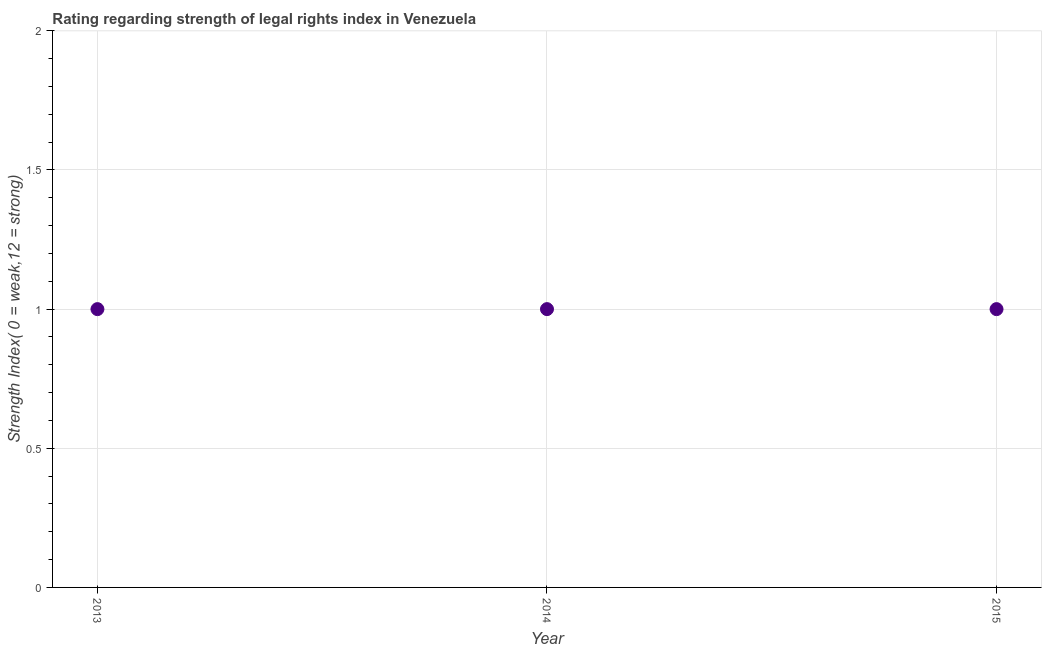What is the strength of legal rights index in 2015?
Your answer should be very brief. 1. Across all years, what is the maximum strength of legal rights index?
Make the answer very short. 1. Across all years, what is the minimum strength of legal rights index?
Provide a succinct answer. 1. In which year was the strength of legal rights index minimum?
Your response must be concise. 2013. What is the sum of the strength of legal rights index?
Your answer should be compact. 3. What is the average strength of legal rights index per year?
Provide a short and direct response. 1. What is the ratio of the strength of legal rights index in 2013 to that in 2014?
Keep it short and to the point. 1. Is the difference between the strength of legal rights index in 2014 and 2015 greater than the difference between any two years?
Make the answer very short. Yes. What is the difference between the highest and the second highest strength of legal rights index?
Your answer should be compact. 0. How many dotlines are there?
Give a very brief answer. 1. How many years are there in the graph?
Your response must be concise. 3. Are the values on the major ticks of Y-axis written in scientific E-notation?
Give a very brief answer. No. Does the graph contain any zero values?
Your response must be concise. No. What is the title of the graph?
Ensure brevity in your answer.  Rating regarding strength of legal rights index in Venezuela. What is the label or title of the X-axis?
Make the answer very short. Year. What is the label or title of the Y-axis?
Keep it short and to the point. Strength Index( 0 = weak,12 = strong). What is the difference between the Strength Index( 0 = weak,12 = strong) in 2013 and 2014?
Your answer should be compact. 0. What is the ratio of the Strength Index( 0 = weak,12 = strong) in 2013 to that in 2014?
Ensure brevity in your answer.  1. What is the ratio of the Strength Index( 0 = weak,12 = strong) in 2013 to that in 2015?
Provide a succinct answer. 1. 